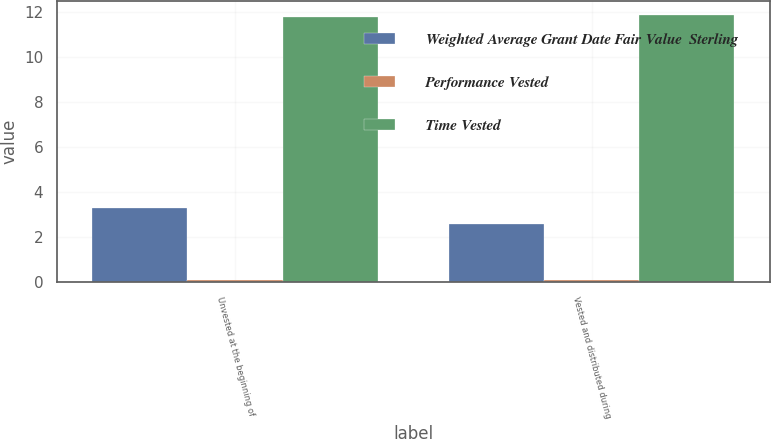Convert chart. <chart><loc_0><loc_0><loc_500><loc_500><stacked_bar_chart><ecel><fcel>Unvested at the beginning of<fcel>Vested and distributed during<nl><fcel>Weighted Average Grant Date Fair Value  Sterling<fcel>3.3<fcel>2.6<nl><fcel>Performance Vested<fcel>0.1<fcel>0.1<nl><fcel>Time Vested<fcel>11.8<fcel>11.89<nl></chart> 